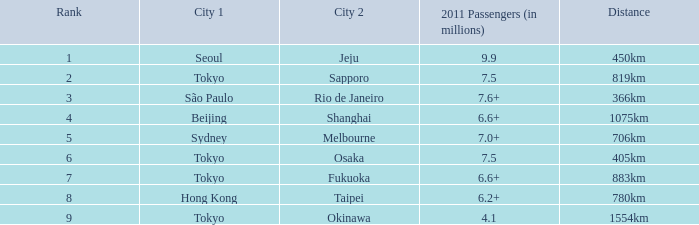In 2011, which city is listed first along the route that had 7.6+ million passengers? São Paulo. 